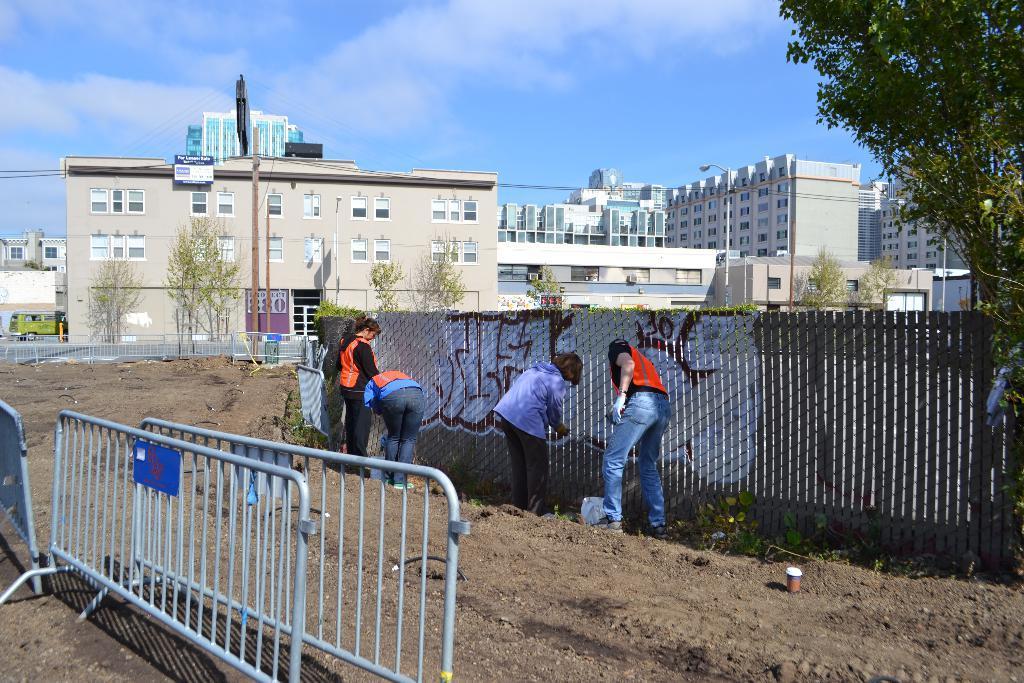Please provide a concise description of this image. On the left side we can see fences on the ground. In the background there are few persons standing at the fence and a person is in motion and we can see drawings on the fence, trees, buildings, poles, light poles, windows, vehicle on the left side on the road, fence and clouds in the sky. 